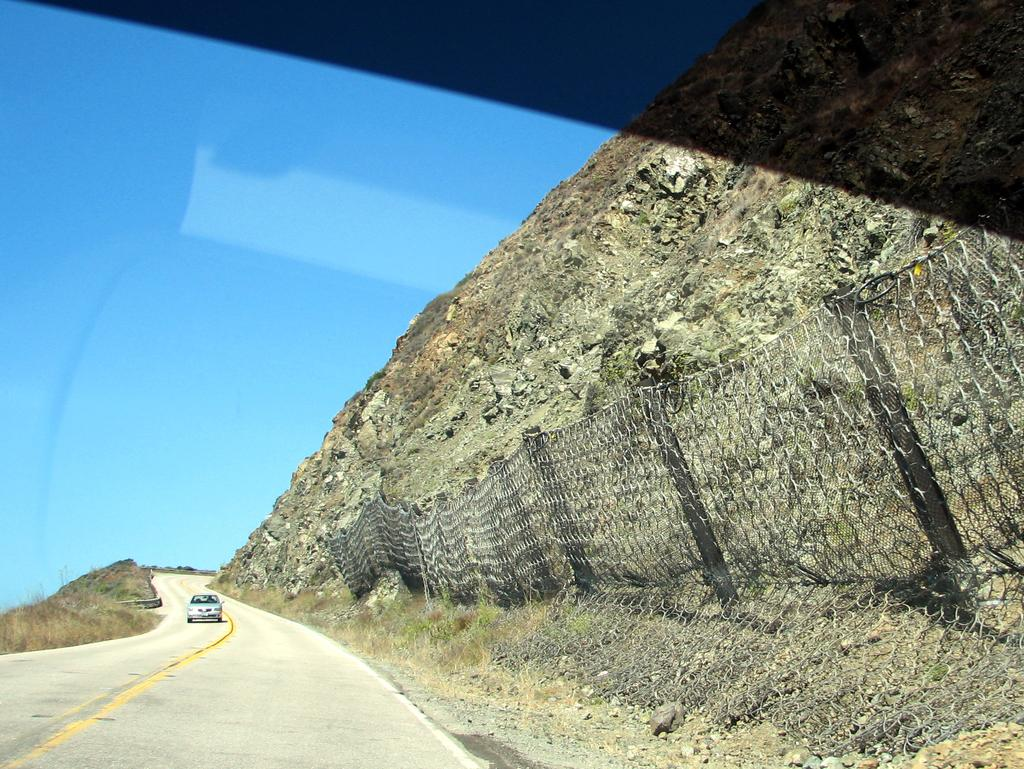What is the main subject of the image? There is a car on the road in the image. What can be seen on the right side of the image? There is a mountain and a fence on the right side of the image. What type of vegetation is on the left side of the image? There is grass on the left side of the image. What is visible in the background of the image? The sky is visible in the background of the image. Where is the grain shop located in the image? There is no grain shop present in the image. Can you see any pipes in the image? There are no pipes visible in the image. 